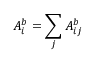<formula> <loc_0><loc_0><loc_500><loc_500>A _ { i } ^ { b } = \sum _ { j } A _ { i j } ^ { b }</formula> 